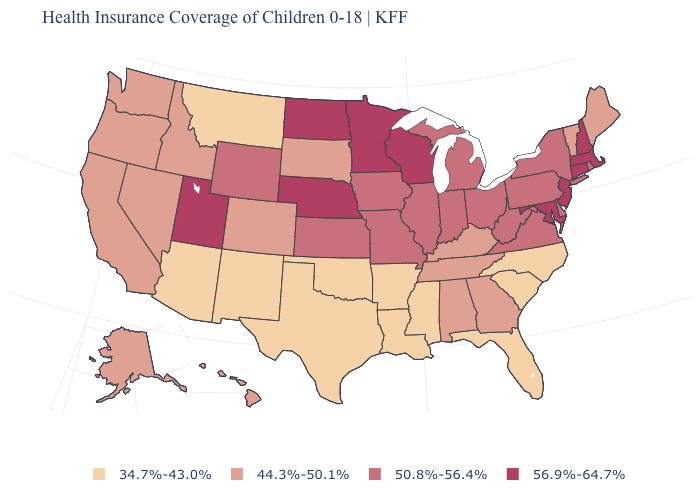Does the map have missing data?
Be succinct. No. Does California have the same value as Colorado?
Write a very short answer. Yes. What is the value of Minnesota?
Quick response, please. 56.9%-64.7%. What is the value of Utah?
Short answer required. 56.9%-64.7%. Among the states that border Florida , which have the highest value?
Answer briefly. Alabama, Georgia. Name the states that have a value in the range 56.9%-64.7%?
Keep it brief. Connecticut, Maryland, Massachusetts, Minnesota, Nebraska, New Hampshire, New Jersey, North Dakota, Utah, Wisconsin. Name the states that have a value in the range 50.8%-56.4%?
Concise answer only. Delaware, Illinois, Indiana, Iowa, Kansas, Michigan, Missouri, New York, Ohio, Pennsylvania, Rhode Island, Virginia, West Virginia, Wyoming. Does the first symbol in the legend represent the smallest category?
Short answer required. Yes. What is the lowest value in states that border Texas?
Give a very brief answer. 34.7%-43.0%. What is the value of Arkansas?
Be succinct. 34.7%-43.0%. What is the value of North Dakota?
Write a very short answer. 56.9%-64.7%. Name the states that have a value in the range 34.7%-43.0%?
Answer briefly. Arizona, Arkansas, Florida, Louisiana, Mississippi, Montana, New Mexico, North Carolina, Oklahoma, South Carolina, Texas. Does the first symbol in the legend represent the smallest category?
Concise answer only. Yes. Which states have the lowest value in the USA?
Answer briefly. Arizona, Arkansas, Florida, Louisiana, Mississippi, Montana, New Mexico, North Carolina, Oklahoma, South Carolina, Texas. What is the highest value in states that border Utah?
Keep it brief. 50.8%-56.4%. 